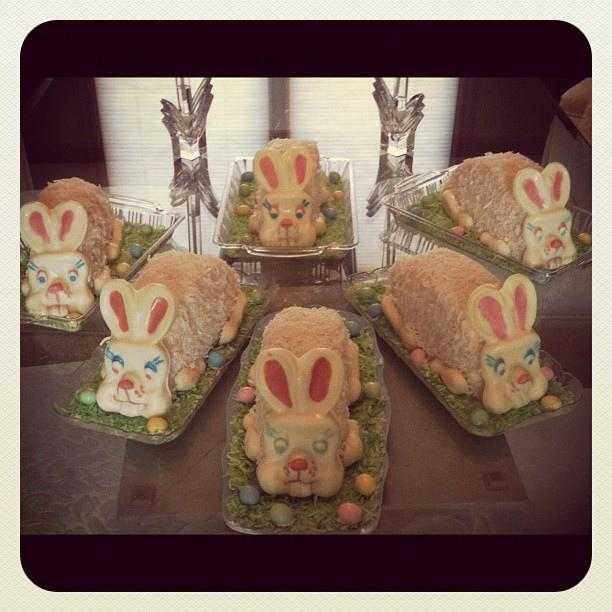What kind of animals are these cakes prepared to the shape of? rabbit 